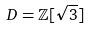<formula> <loc_0><loc_0><loc_500><loc_500>D = \mathbb { Z } [ \sqrt { 3 } ]</formula> 